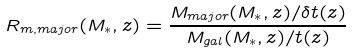<formula> <loc_0><loc_0><loc_500><loc_500>R _ { m , m a j o r } ( M _ { * } , z ) = \frac { M _ { m a j o r } ( M _ { * } , z ) / \delta t ( z ) } { M _ { g a l } ( M _ { * } , z ) / t ( z ) }</formula> 